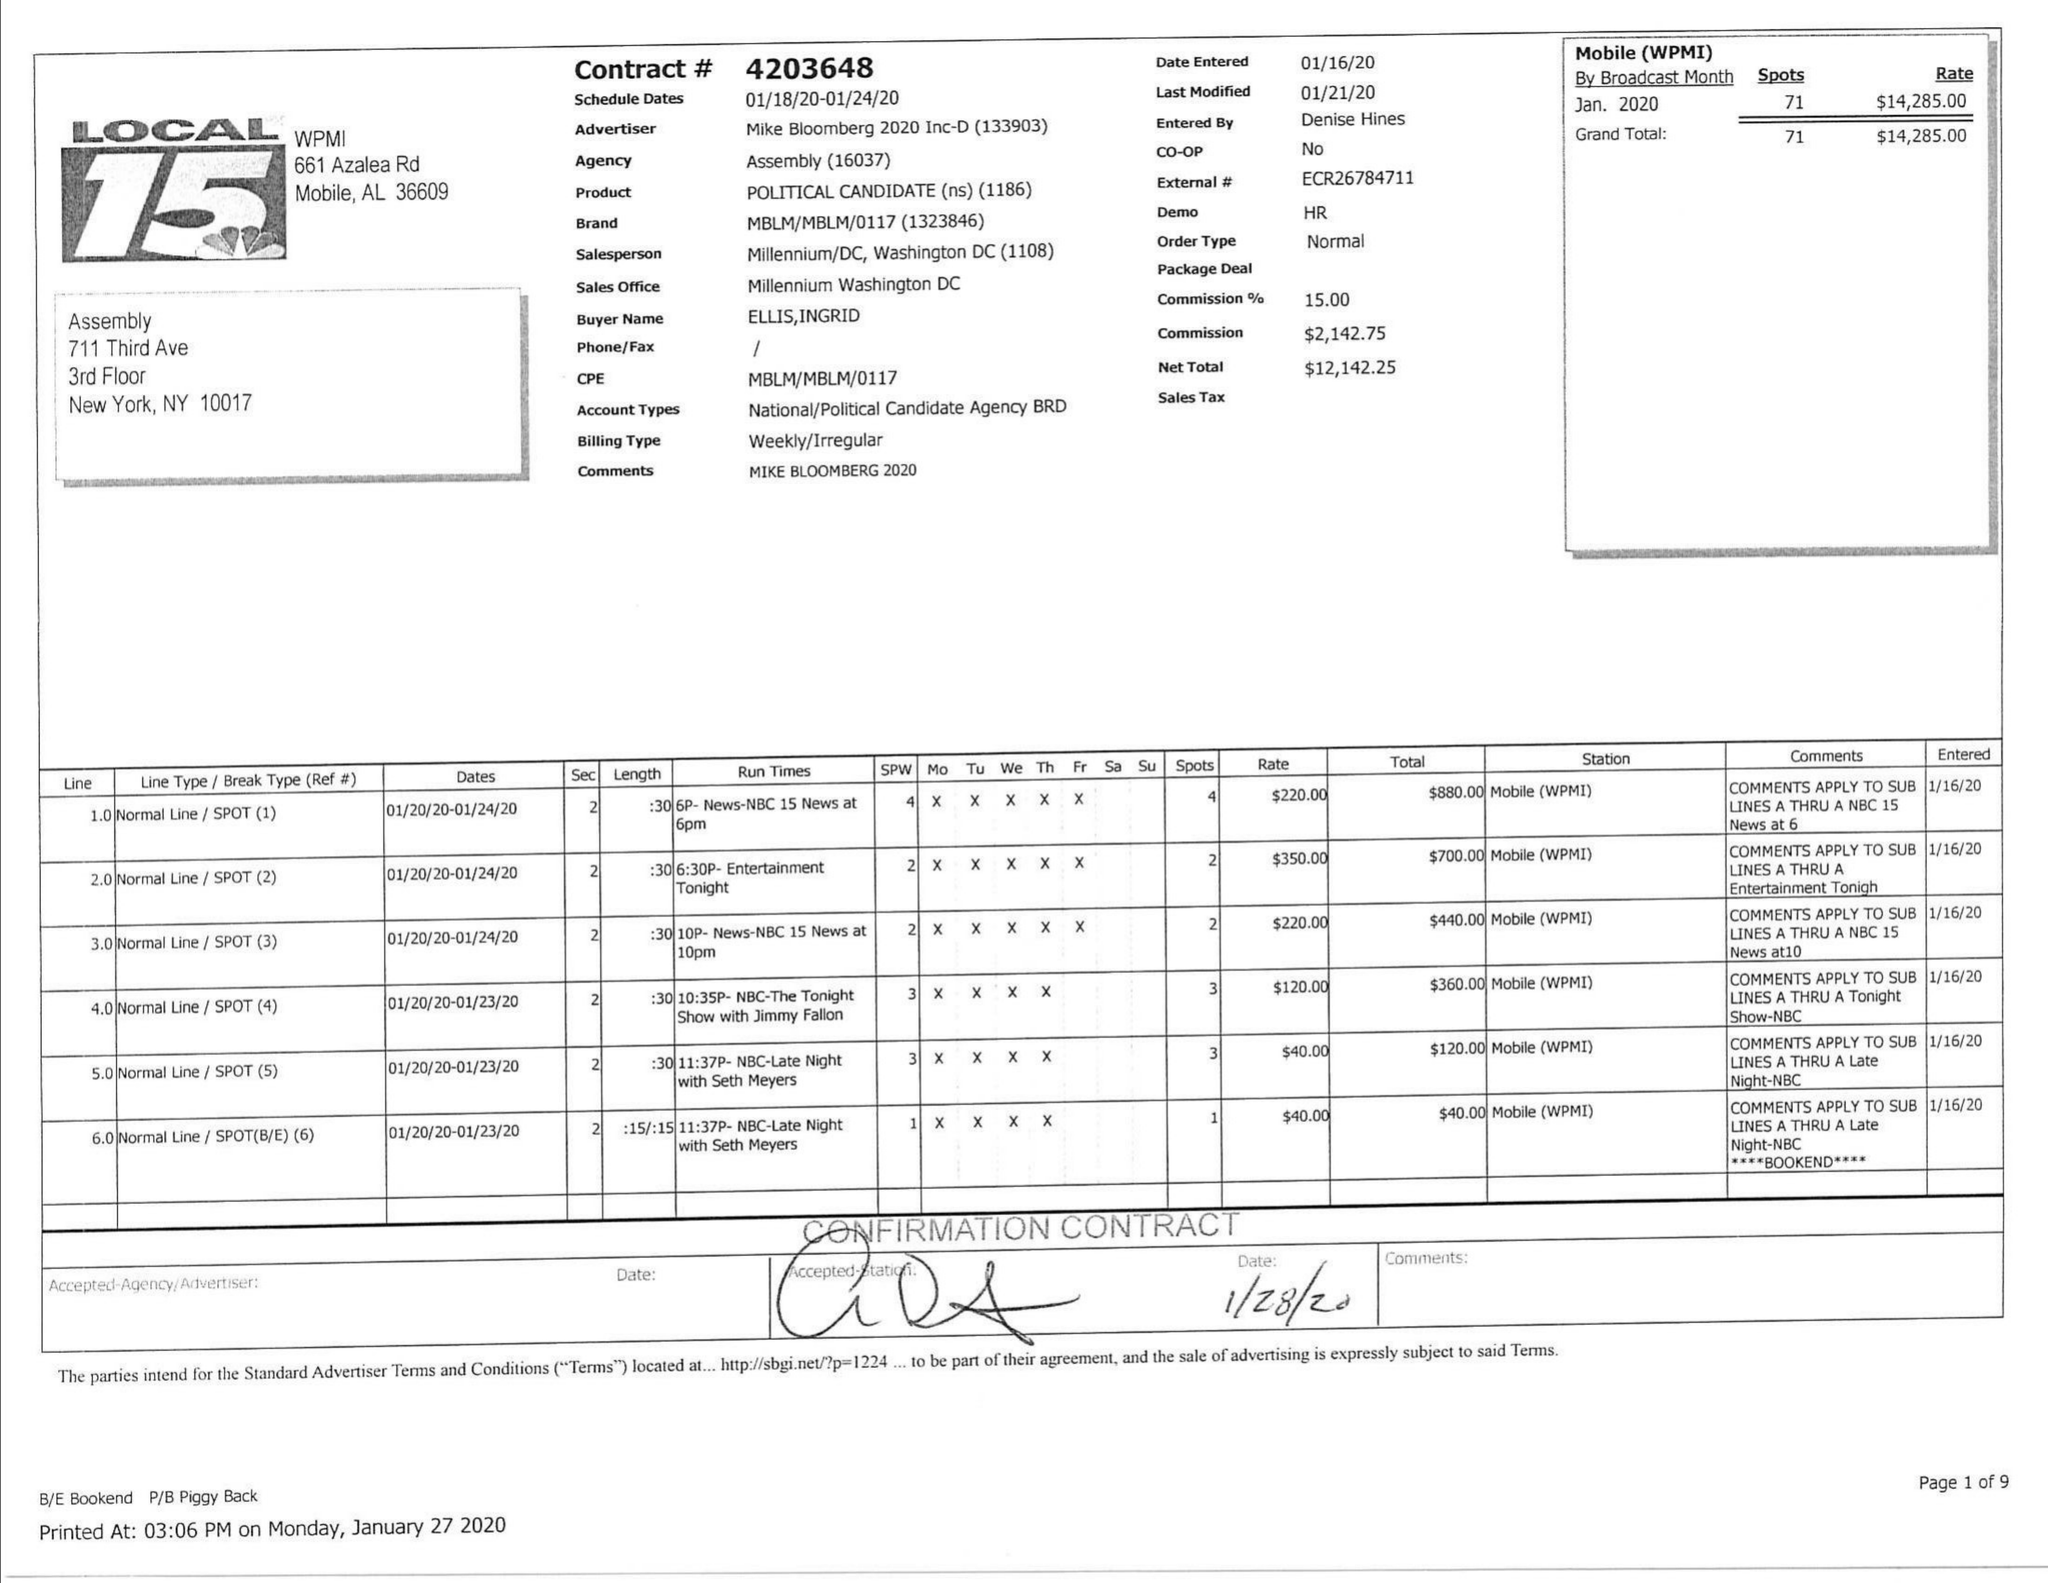What is the value for the advertiser?
Answer the question using a single word or phrase. MIKE BLOOMBERG 2020 INC-D 